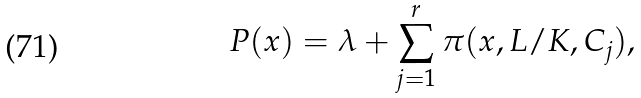<formula> <loc_0><loc_0><loc_500><loc_500>P ( x ) = \lambda + \sum _ { j = 1 } ^ { r } \pi ( x , L / K , C _ { j } ) ,</formula> 